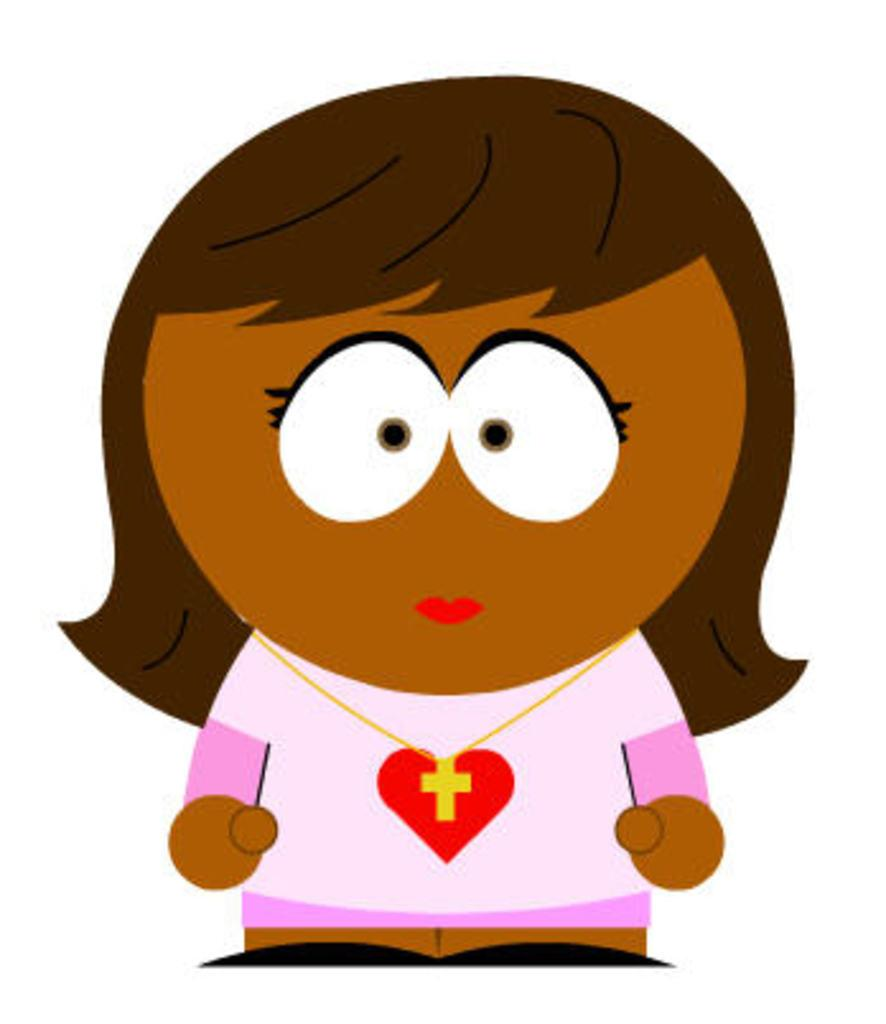What type of character is in the image? There is a cartoon girl in the image. What is the color of the girl's hair? The girl has brown hair. What is the color of the girl's face? The girl has a brown face. What is the girl wearing in the image? The girl is wearing a white T-shirt. What color are the borders of the girl's T-shirt? The T-shirt has pink borders. What nation is the girl representing in the image? The image does not depict the girl representing any specific nation. Is the girl standing on a slope in the image? There is no slope present in the image; it is a flat surface. 